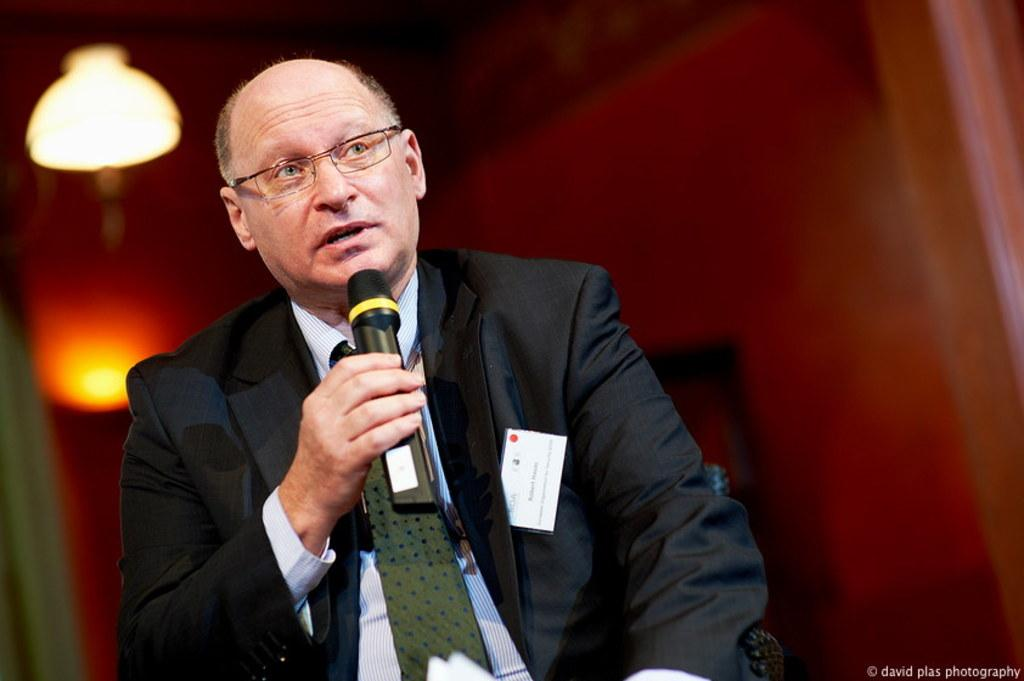What is the main subject of the image? There is a person in the image. What is the person doing in the image? The person is sitting and holding a mic in their hand. Can you describe the background of the image? The background of the image is blurry. Who is the creator of the harbor in the image? There is no harbor present in the image, so it is not possible to determine who the creator might be. 